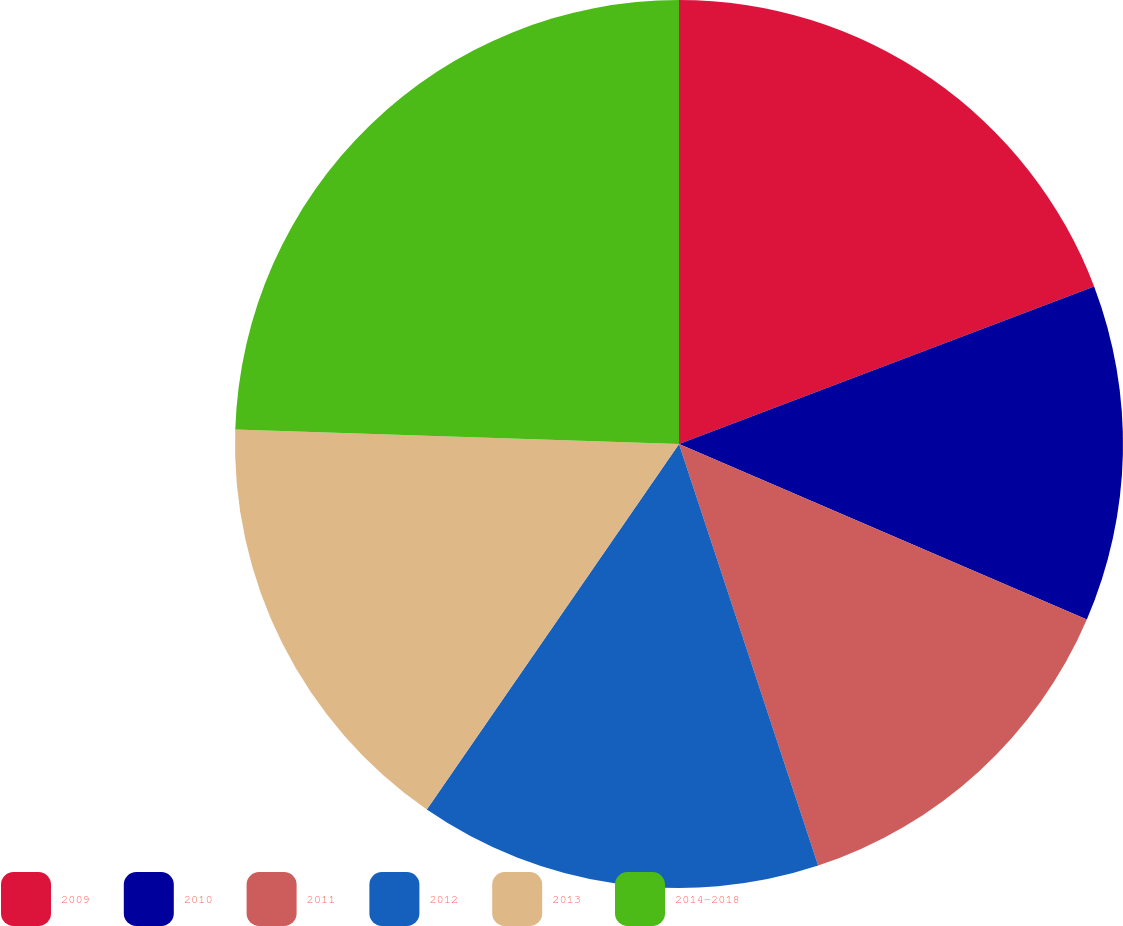Convert chart. <chart><loc_0><loc_0><loc_500><loc_500><pie_chart><fcel>2009<fcel>2010<fcel>2011<fcel>2012<fcel>2013<fcel>2014-2018<nl><fcel>19.23%<fcel>12.24%<fcel>13.46%<fcel>14.69%<fcel>15.91%<fcel>24.48%<nl></chart> 